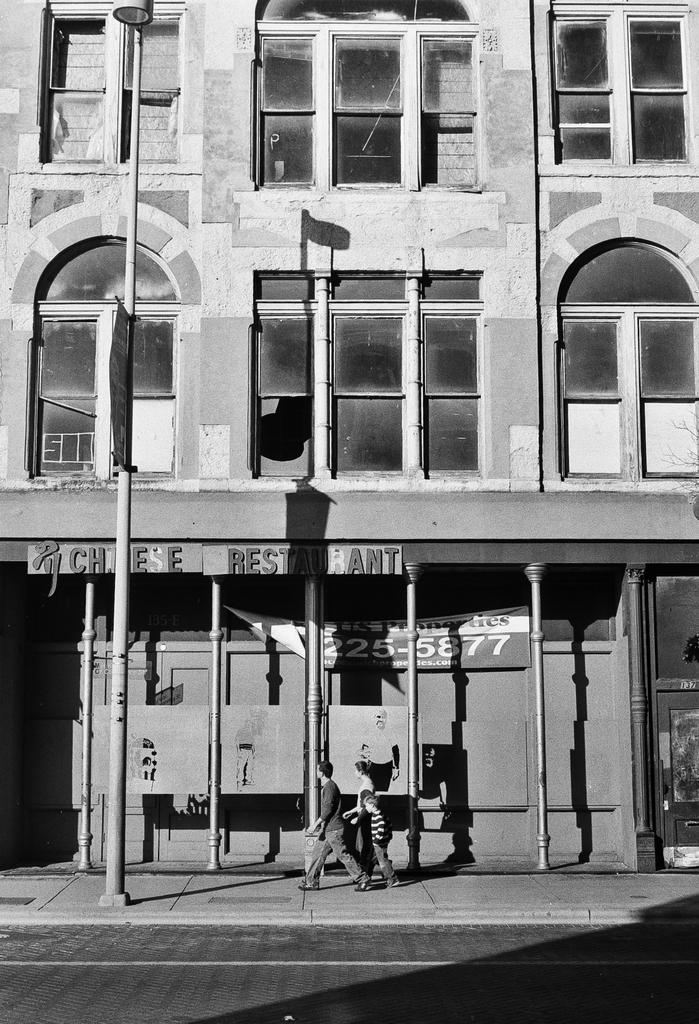Could you give a brief overview of what you see in this image? In the image we can see the black and white picture of the building and these are the windows of the building. We can see there are even two people and a child walking and they are wearing clothes. Here we can see the pole, footpath and the road. 